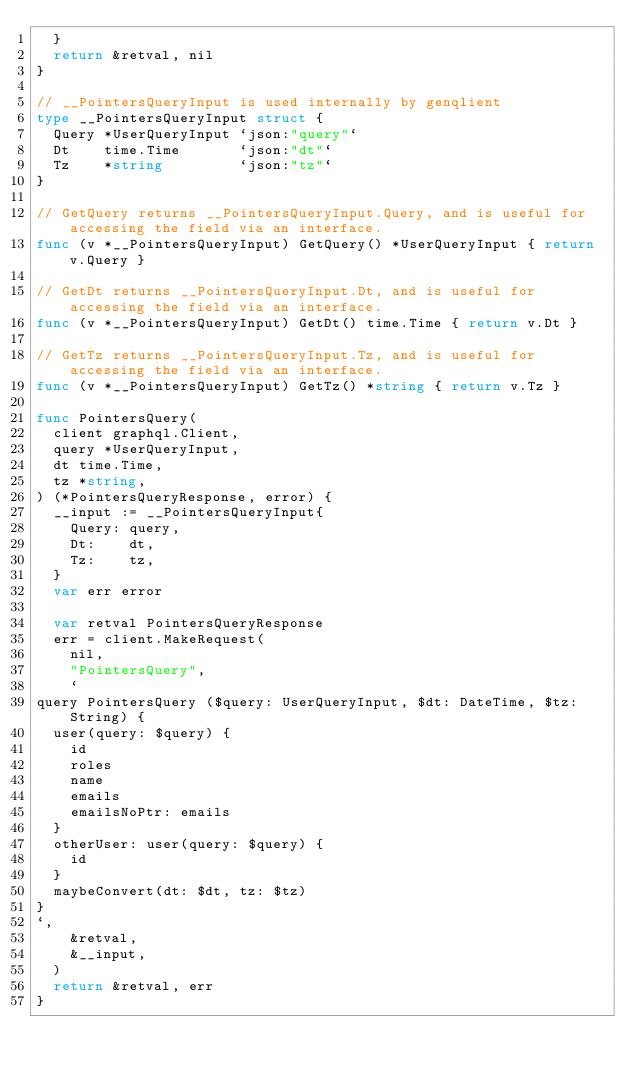<code> <loc_0><loc_0><loc_500><loc_500><_Go_>	}
	return &retval, nil
}

// __PointersQueryInput is used internally by genqlient
type __PointersQueryInput struct {
	Query *UserQueryInput `json:"query"`
	Dt    time.Time       `json:"dt"`
	Tz    *string         `json:"tz"`
}

// GetQuery returns __PointersQueryInput.Query, and is useful for accessing the field via an interface.
func (v *__PointersQueryInput) GetQuery() *UserQueryInput { return v.Query }

// GetDt returns __PointersQueryInput.Dt, and is useful for accessing the field via an interface.
func (v *__PointersQueryInput) GetDt() time.Time { return v.Dt }

// GetTz returns __PointersQueryInput.Tz, and is useful for accessing the field via an interface.
func (v *__PointersQueryInput) GetTz() *string { return v.Tz }

func PointersQuery(
	client graphql.Client,
	query *UserQueryInput,
	dt time.Time,
	tz *string,
) (*PointersQueryResponse, error) {
	__input := __PointersQueryInput{
		Query: query,
		Dt:    dt,
		Tz:    tz,
	}
	var err error

	var retval PointersQueryResponse
	err = client.MakeRequest(
		nil,
		"PointersQuery",
		`
query PointersQuery ($query: UserQueryInput, $dt: DateTime, $tz: String) {
	user(query: $query) {
		id
		roles
		name
		emails
		emailsNoPtr: emails
	}
	otherUser: user(query: $query) {
		id
	}
	maybeConvert(dt: $dt, tz: $tz)
}
`,
		&retval,
		&__input,
	)
	return &retval, err
}

</code> 